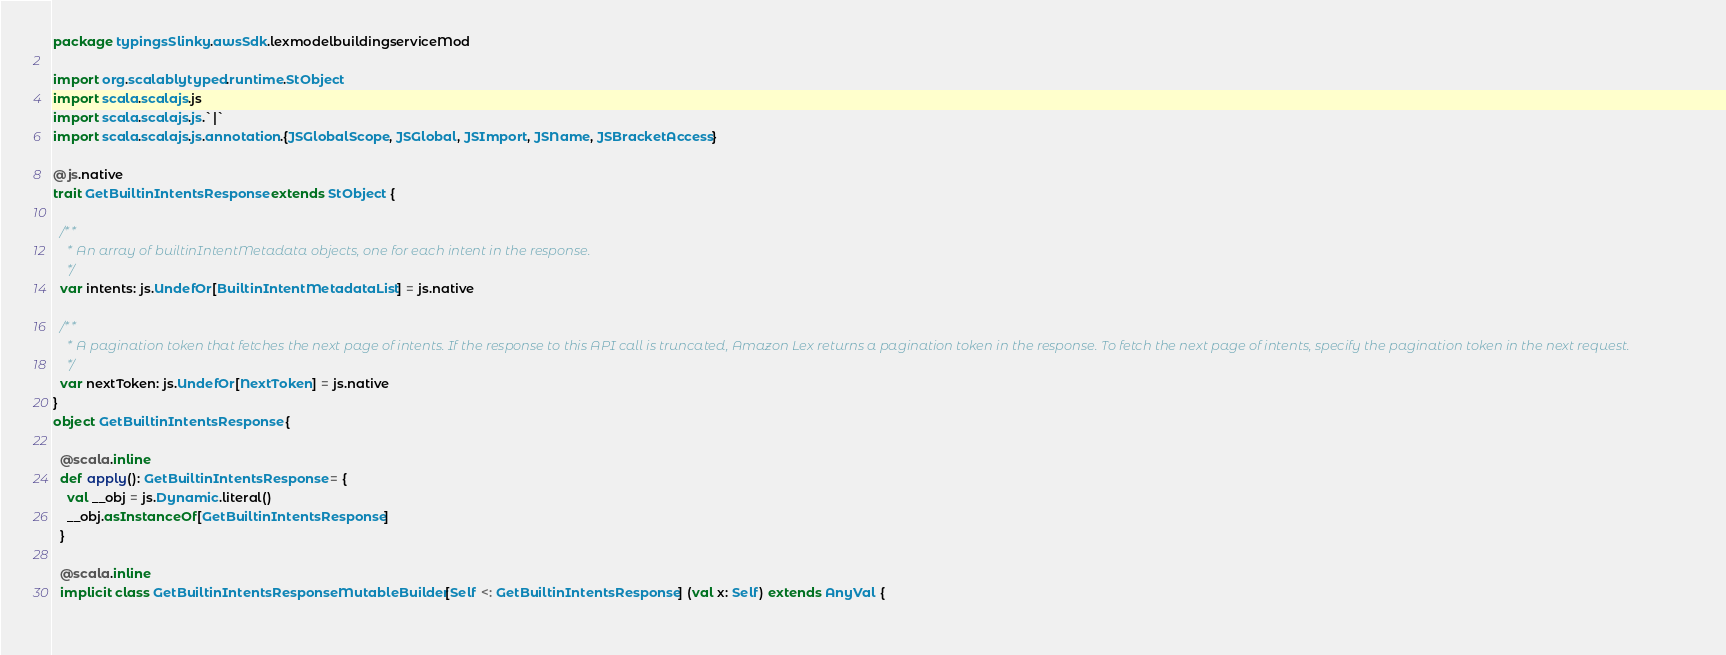Convert code to text. <code><loc_0><loc_0><loc_500><loc_500><_Scala_>package typingsSlinky.awsSdk.lexmodelbuildingserviceMod

import org.scalablytyped.runtime.StObject
import scala.scalajs.js
import scala.scalajs.js.`|`
import scala.scalajs.js.annotation.{JSGlobalScope, JSGlobal, JSImport, JSName, JSBracketAccess}

@js.native
trait GetBuiltinIntentsResponse extends StObject {
  
  /**
    * An array of builtinIntentMetadata objects, one for each intent in the response.
    */
  var intents: js.UndefOr[BuiltinIntentMetadataList] = js.native
  
  /**
    * A pagination token that fetches the next page of intents. If the response to this API call is truncated, Amazon Lex returns a pagination token in the response. To fetch the next page of intents, specify the pagination token in the next request.
    */
  var nextToken: js.UndefOr[NextToken] = js.native
}
object GetBuiltinIntentsResponse {
  
  @scala.inline
  def apply(): GetBuiltinIntentsResponse = {
    val __obj = js.Dynamic.literal()
    __obj.asInstanceOf[GetBuiltinIntentsResponse]
  }
  
  @scala.inline
  implicit class GetBuiltinIntentsResponseMutableBuilder[Self <: GetBuiltinIntentsResponse] (val x: Self) extends AnyVal {
    </code> 